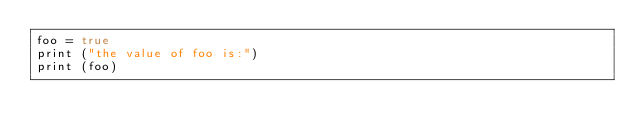<code> <loc_0><loc_0><loc_500><loc_500><_Lua_>foo = true
print ("the value of foo is:")
print (foo)</code> 